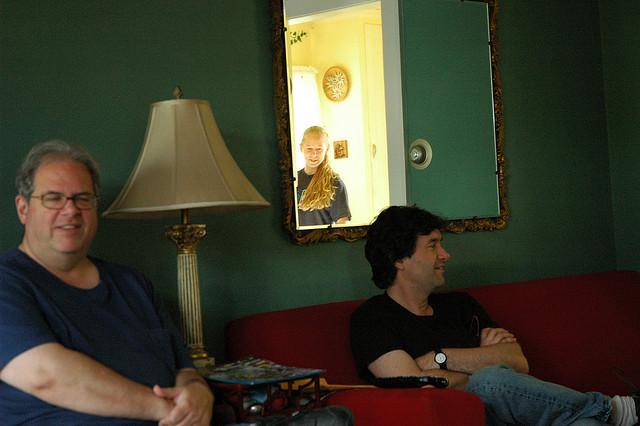Where is the temperature gage?
Keep it brief. In mirror. Is the light turned on?
Concise answer only. No. What color is the wall?
Be succinct. Green. Who can be seen in the mirror?
Be succinct. Girl. 